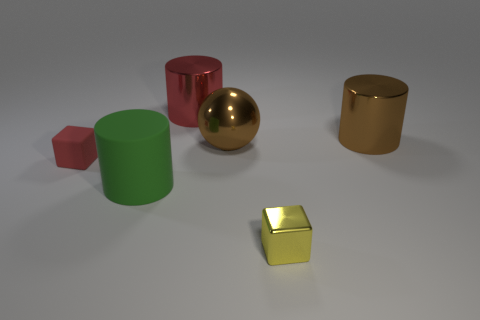There is a brown metal object that is on the right side of the large brown ball; is it the same shape as the tiny thing that is right of the brown sphere?
Keep it short and to the point. No. There is a red thing right of the rubber object that is on the left side of the big matte cylinder; what shape is it?
Provide a short and direct response. Cylinder. Are there any yellow cubes made of the same material as the red block?
Provide a short and direct response. No. There is a big cylinder that is left of the red metal cylinder; what material is it?
Your answer should be compact. Rubber. What is the brown cylinder made of?
Your answer should be compact. Metal. Are the cube that is to the right of the small red thing and the big brown ball made of the same material?
Make the answer very short. Yes. Are there fewer tiny metal blocks left of the big green matte thing than brown cylinders?
Offer a very short reply. Yes. There is a matte object that is the same size as the sphere; what is its color?
Make the answer very short. Green. What number of large metal things have the same shape as the green rubber object?
Make the answer very short. 2. There is a cylinder that is in front of the small rubber block; what is its color?
Make the answer very short. Green. 